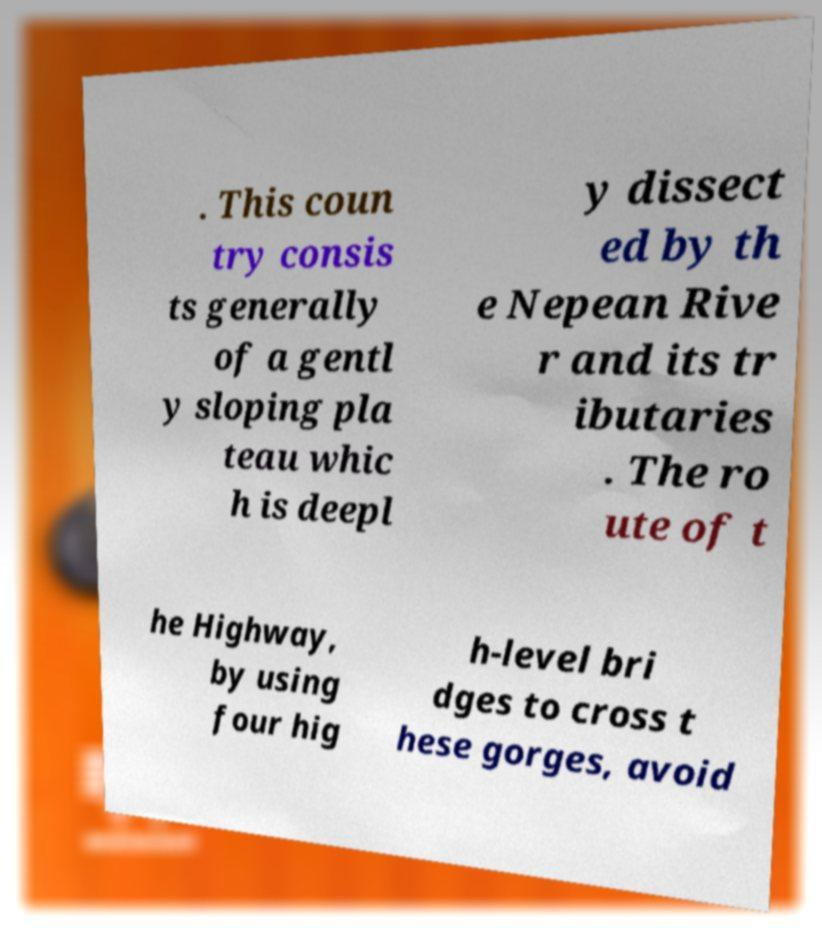For documentation purposes, I need the text within this image transcribed. Could you provide that? . This coun try consis ts generally of a gentl y sloping pla teau whic h is deepl y dissect ed by th e Nepean Rive r and its tr ibutaries . The ro ute of t he Highway, by using four hig h-level bri dges to cross t hese gorges, avoid 